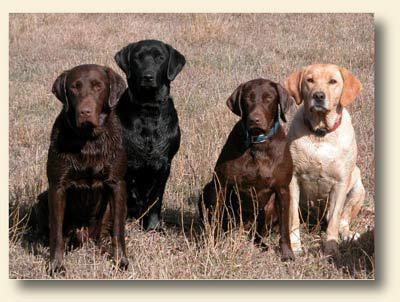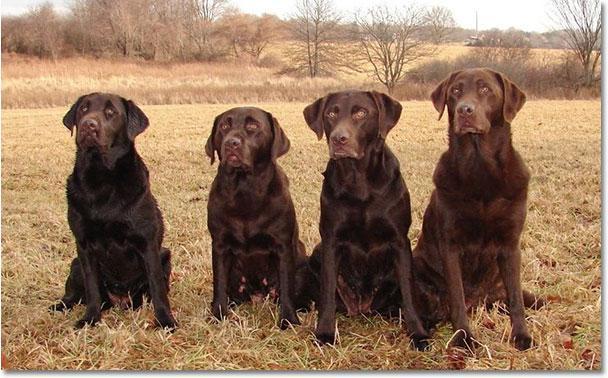The first image is the image on the left, the second image is the image on the right. Considering the images on both sides, is "All of the dogs are sitting." valid? Answer yes or no. Yes. 